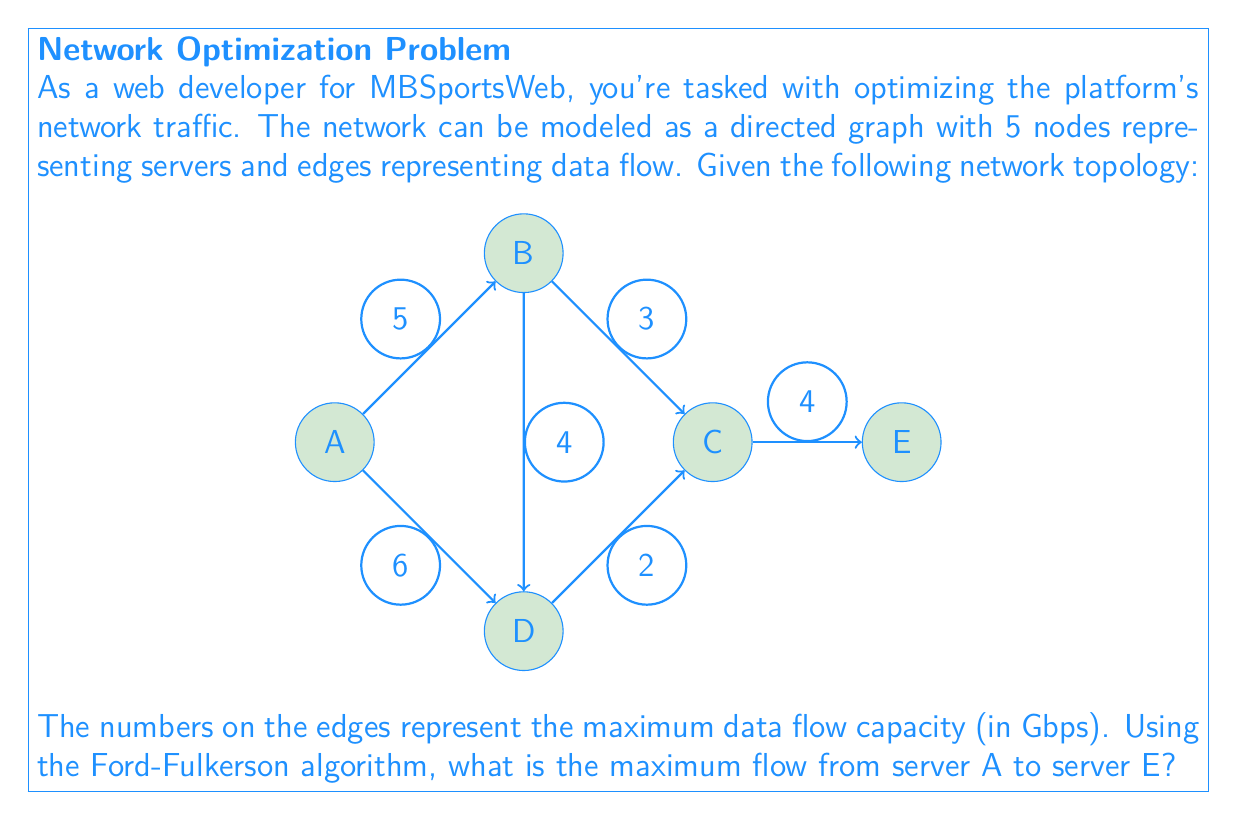Teach me how to tackle this problem. To solve this problem using the Ford-Fulkerson algorithm, we'll follow these steps:

1) Initialize the flow on all edges to 0.

2) Find an augmenting path from A to E using DFS or BFS. We'll use DFS:
   Path 1: A -> B -> C -> E with a residual capacity of min(5, 3, 4) = 3
   Update flow: A->B: 3, B->C: 3, C->E: 3

3) Find another augmenting path:
   Path 2: A -> D -> C -> E with a residual capacity of min(6, 2, 4-3) = 1
   Update flow: A->D: 1, D->C: 1, C->E: 4

4) Find another augmenting path:
   Path 3: A -> B -> D -> C -> E with a residual capacity of min(5-3, 4, 2-1, 4-4) = 1
   Update flow: A->B: 4, B->D: 1, D->C: 2, C->E: 4 (unchanged)

5) No more augmenting paths exist, so we've found the maximum flow.

The maximum flow is the sum of the flows leaving the source A:
$$\text{Max Flow} = \text{Flow}(A \to B) + \text{Flow}(A \to D) = 4 + 1 = 5 \text{ Gbps}$$

This can be verified by checking the flow into the sink E:
$$\text{Flow into E} = \text{Flow}(C \to E) = 4 \text{ Gbps}$$

The discrepancy (5 vs 4) is due to the bottleneck at C->E, which has a maximum capacity of 4 Gbps.
Answer: 4 Gbps 